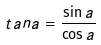Convert formula to latex. <formula><loc_0><loc_0><loc_500><loc_500>t a n a = \frac { \sin a } { \cos a }</formula> 